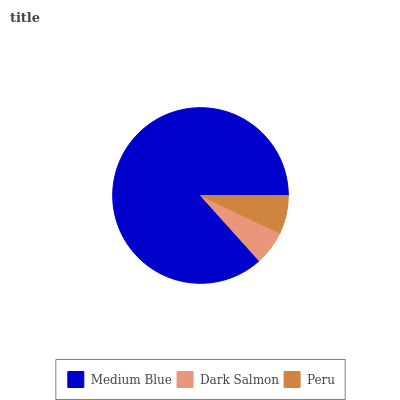Is Dark Salmon the minimum?
Answer yes or no. Yes. Is Medium Blue the maximum?
Answer yes or no. Yes. Is Peru the minimum?
Answer yes or no. No. Is Peru the maximum?
Answer yes or no. No. Is Peru greater than Dark Salmon?
Answer yes or no. Yes. Is Dark Salmon less than Peru?
Answer yes or no. Yes. Is Dark Salmon greater than Peru?
Answer yes or no. No. Is Peru less than Dark Salmon?
Answer yes or no. No. Is Peru the high median?
Answer yes or no. Yes. Is Peru the low median?
Answer yes or no. Yes. Is Dark Salmon the high median?
Answer yes or no. No. Is Medium Blue the low median?
Answer yes or no. No. 